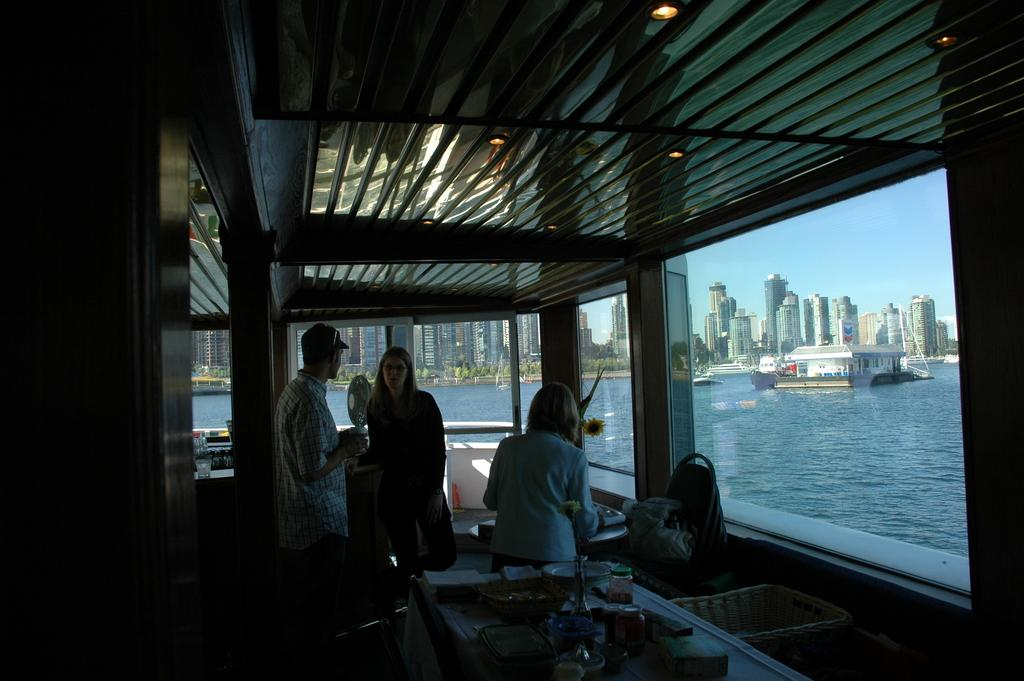How many people are in the image? There are three persons in the image. What is the setting of the image? The persons appear to be in a ship. What is the structure above the persons in the image? There is a roof visible in the image. What can be seen to the right of the image? There is water to the right of the image. What type of buildings can be seen in the background of the image? There are skyscrapers in the background of the image. What color is the gold jellyfish swimming in the water in the image? There is no gold jellyfish present in the image; it only features three persons in a ship, a roof, water, and skyscrapers in the background. 